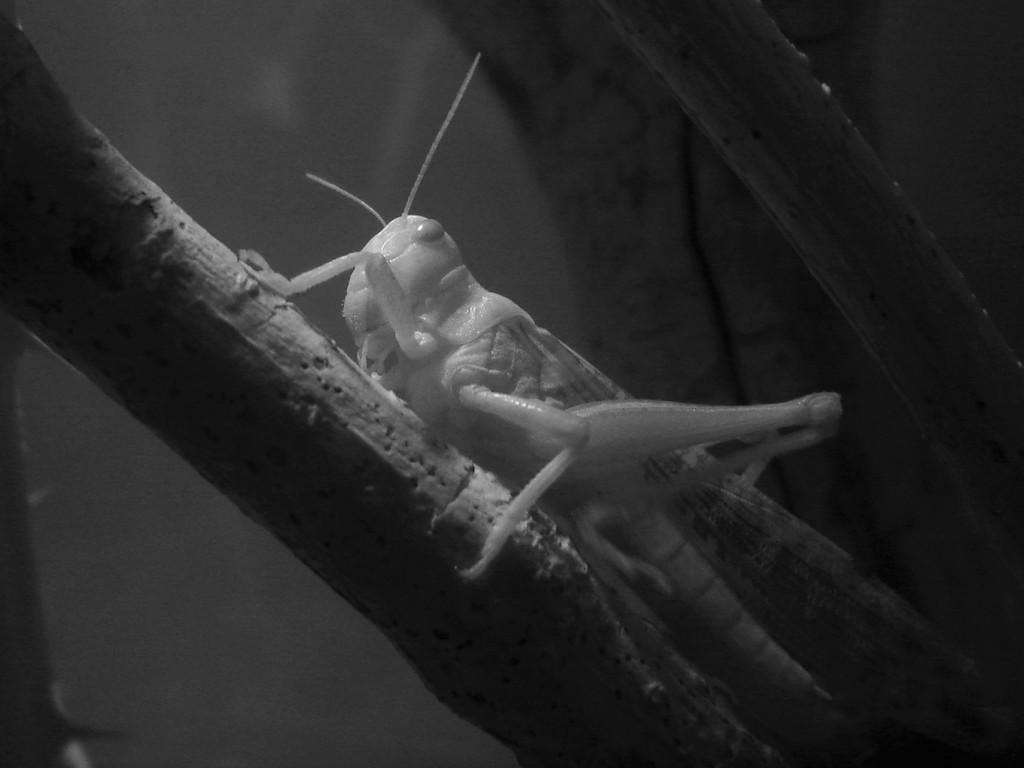What is present on the tree in the image? There is an insect on a tree in the image. What can be seen in the background of the image? There is a wall visible in the background of the image. Is there a kitten making a payment to the insect in the image? There is no kitten or payment present in the image; it only features an insect on a tree and a wall in the background. 